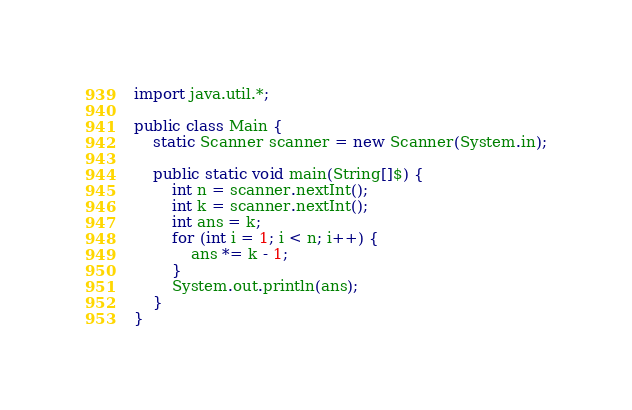Convert code to text. <code><loc_0><loc_0><loc_500><loc_500><_Java_>import java.util.*;

public class Main {
    static Scanner scanner = new Scanner(System.in);

    public static void main(String[]$) {
        int n = scanner.nextInt();
        int k = scanner.nextInt();
        int ans = k;
        for (int i = 1; i < n; i++) {
            ans *= k - 1;
        }
        System.out.println(ans);
    }
}</code> 